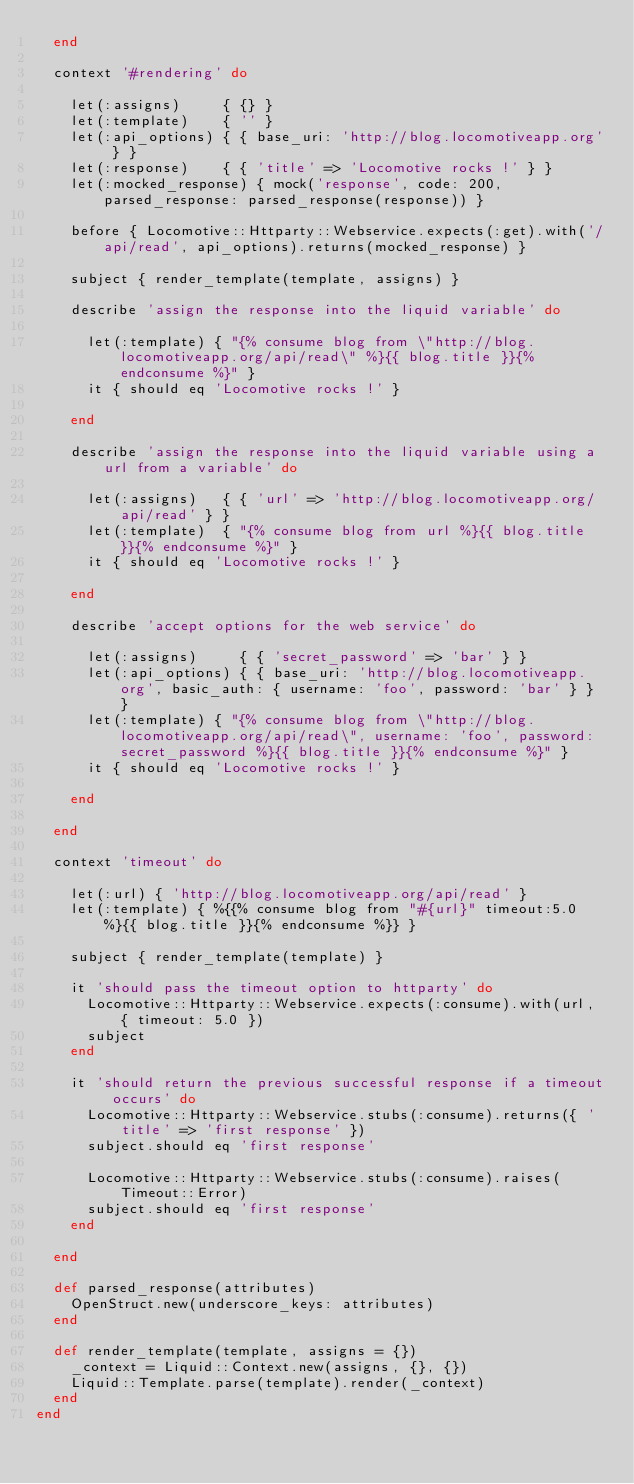<code> <loc_0><loc_0><loc_500><loc_500><_Ruby_>  end

  context '#rendering' do

    let(:assigns)     { {} }
    let(:template)    { '' }
    let(:api_options) { { base_uri: 'http://blog.locomotiveapp.org' } }
    let(:response)    { { 'title' => 'Locomotive rocks !' } }
    let(:mocked_response) { mock('response', code: 200, parsed_response: parsed_response(response)) }

    before { Locomotive::Httparty::Webservice.expects(:get).with('/api/read', api_options).returns(mocked_response) }

    subject { render_template(template, assigns) }

    describe 'assign the response into the liquid variable' do

      let(:template) { "{% consume blog from \"http://blog.locomotiveapp.org/api/read\" %}{{ blog.title }}{% endconsume %}" }
      it { should eq 'Locomotive rocks !' }

    end

    describe 'assign the response into the liquid variable using a url from a variable' do

      let(:assigns)   { { 'url' => 'http://blog.locomotiveapp.org/api/read' } }
      let(:template)  { "{% consume blog from url %}{{ blog.title }}{% endconsume %}" }
      it { should eq 'Locomotive rocks !' }

    end

    describe 'accept options for the web service' do

      let(:assigns)     { { 'secret_password' => 'bar' } }
      let(:api_options) { { base_uri: 'http://blog.locomotiveapp.org', basic_auth: { username: 'foo', password: 'bar' } } }
      let(:template) { "{% consume blog from \"http://blog.locomotiveapp.org/api/read\", username: 'foo', password: secret_password %}{{ blog.title }}{% endconsume %}" }
      it { should eq 'Locomotive rocks !' }

    end

  end

  context 'timeout' do

    let(:url) { 'http://blog.locomotiveapp.org/api/read' }
    let(:template) { %{{% consume blog from "#{url}" timeout:5.0 %}{{ blog.title }}{% endconsume %}} }

    subject { render_template(template) }

    it 'should pass the timeout option to httparty' do
      Locomotive::Httparty::Webservice.expects(:consume).with(url, { timeout: 5.0 })
      subject
    end

    it 'should return the previous successful response if a timeout occurs' do
      Locomotive::Httparty::Webservice.stubs(:consume).returns({ 'title' => 'first response' })
      subject.should eq 'first response'

      Locomotive::Httparty::Webservice.stubs(:consume).raises(Timeout::Error)
      subject.should eq 'first response'
    end

  end

  def parsed_response(attributes)
    OpenStruct.new(underscore_keys: attributes)
  end

  def render_template(template, assigns = {})
    _context = Liquid::Context.new(assigns, {}, {})
    Liquid::Template.parse(template).render(_context)
  end
end
</code> 